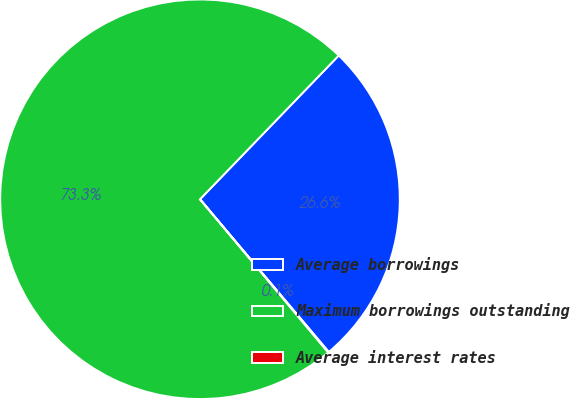<chart> <loc_0><loc_0><loc_500><loc_500><pie_chart><fcel>Average borrowings<fcel>Maximum borrowings outstanding<fcel>Average interest rates<nl><fcel>26.63%<fcel>73.3%<fcel>0.06%<nl></chart> 